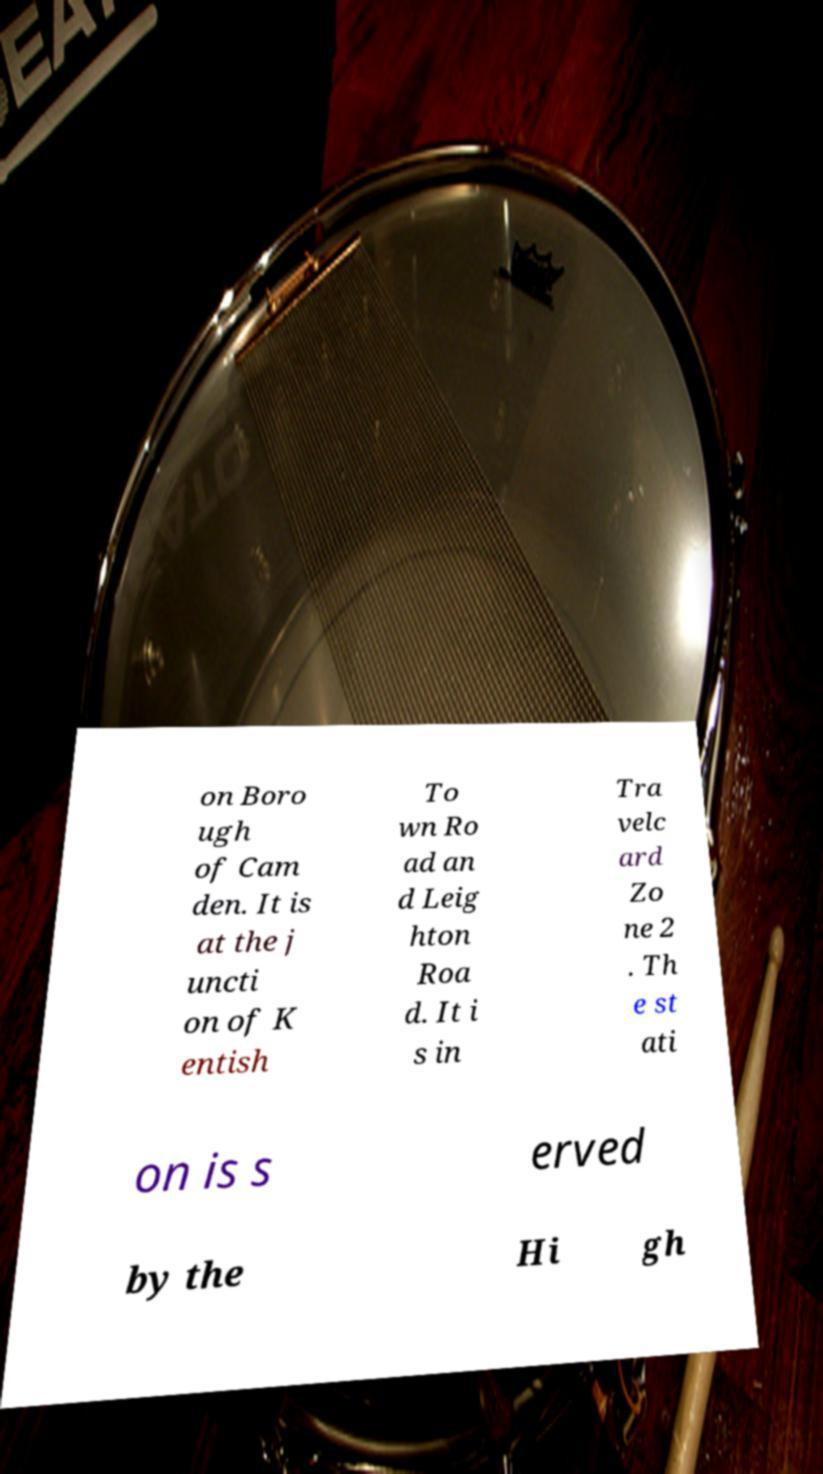Can you accurately transcribe the text from the provided image for me? on Boro ugh of Cam den. It is at the j uncti on of K entish To wn Ro ad an d Leig hton Roa d. It i s in Tra velc ard Zo ne 2 . Th e st ati on is s erved by the Hi gh 